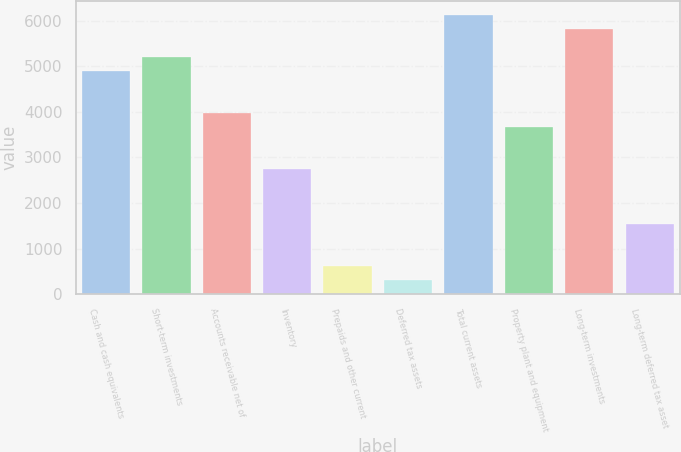<chart> <loc_0><loc_0><loc_500><loc_500><bar_chart><fcel>Cash and cash equivalents<fcel>Short-term investments<fcel>Accounts receivable net of<fcel>Inventory<fcel>Prepaids and other current<fcel>Deferred tax assets<fcel>Total current assets<fcel>Property plant and equipment<fcel>Long-term investments<fcel>Long-term deferred tax asset<nl><fcel>4900.42<fcel>5206.64<fcel>3981.76<fcel>2756.88<fcel>613.34<fcel>307.12<fcel>6125.3<fcel>3675.54<fcel>5819.08<fcel>1532<nl></chart> 